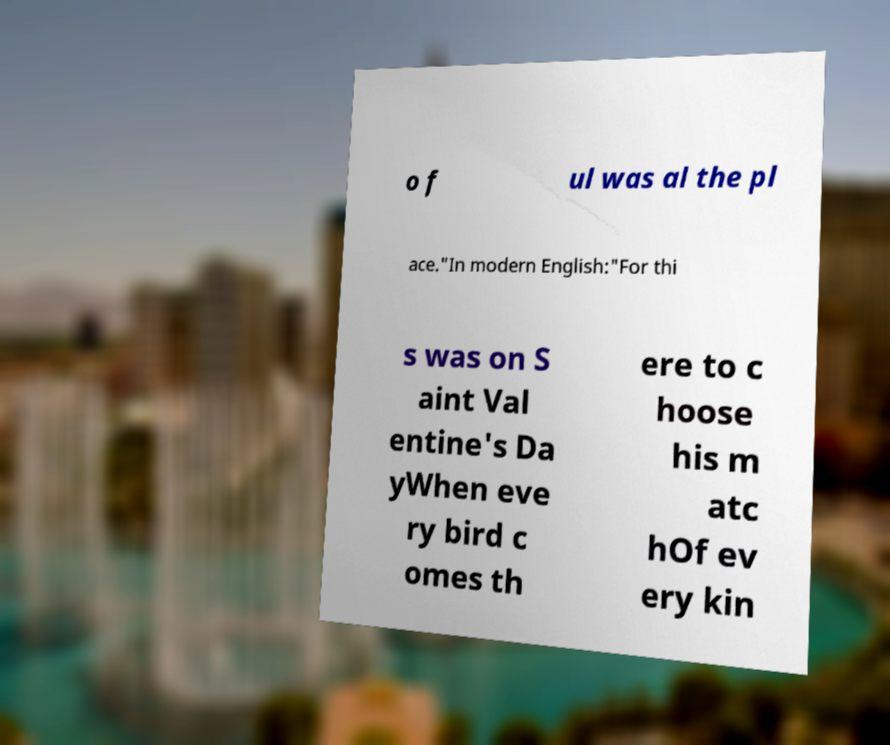What messages or text are displayed in this image? I need them in a readable, typed format. o f ul was al the pl ace."In modern English:"For thi s was on S aint Val entine's Da yWhen eve ry bird c omes th ere to c hoose his m atc hOf ev ery kin 